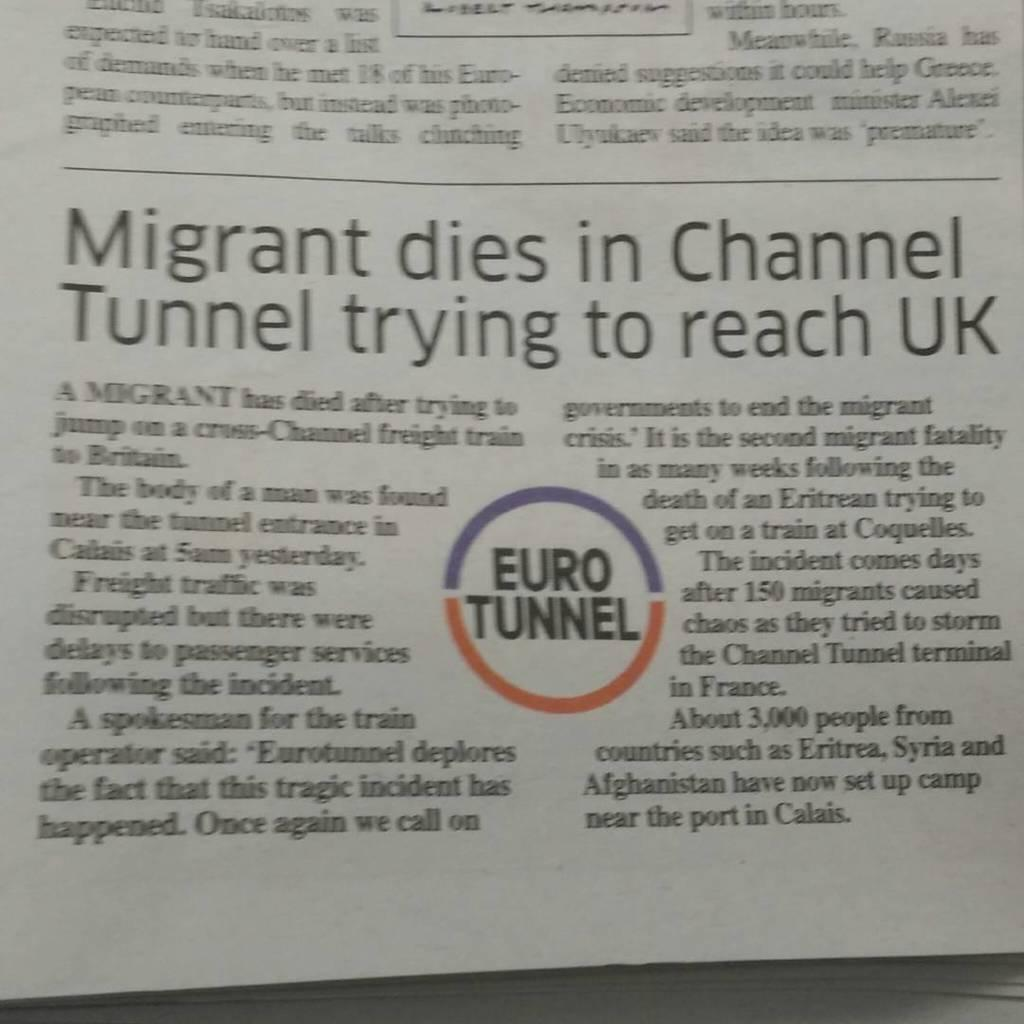<image>
Provide a brief description of the given image. a round area on paper with euro tunnel on it 